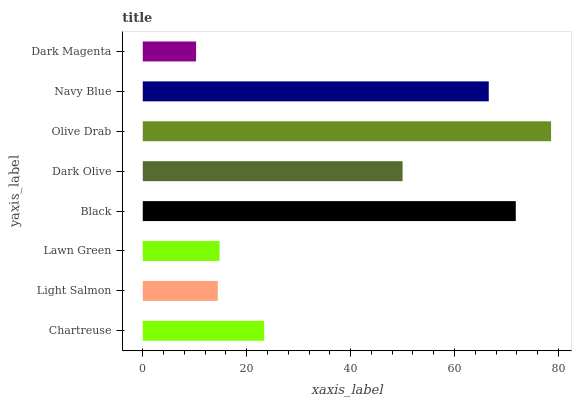Is Dark Magenta the minimum?
Answer yes or no. Yes. Is Olive Drab the maximum?
Answer yes or no. Yes. Is Light Salmon the minimum?
Answer yes or no. No. Is Light Salmon the maximum?
Answer yes or no. No. Is Chartreuse greater than Light Salmon?
Answer yes or no. Yes. Is Light Salmon less than Chartreuse?
Answer yes or no. Yes. Is Light Salmon greater than Chartreuse?
Answer yes or no. No. Is Chartreuse less than Light Salmon?
Answer yes or no. No. Is Dark Olive the high median?
Answer yes or no. Yes. Is Chartreuse the low median?
Answer yes or no. Yes. Is Lawn Green the high median?
Answer yes or no. No. Is Lawn Green the low median?
Answer yes or no. No. 